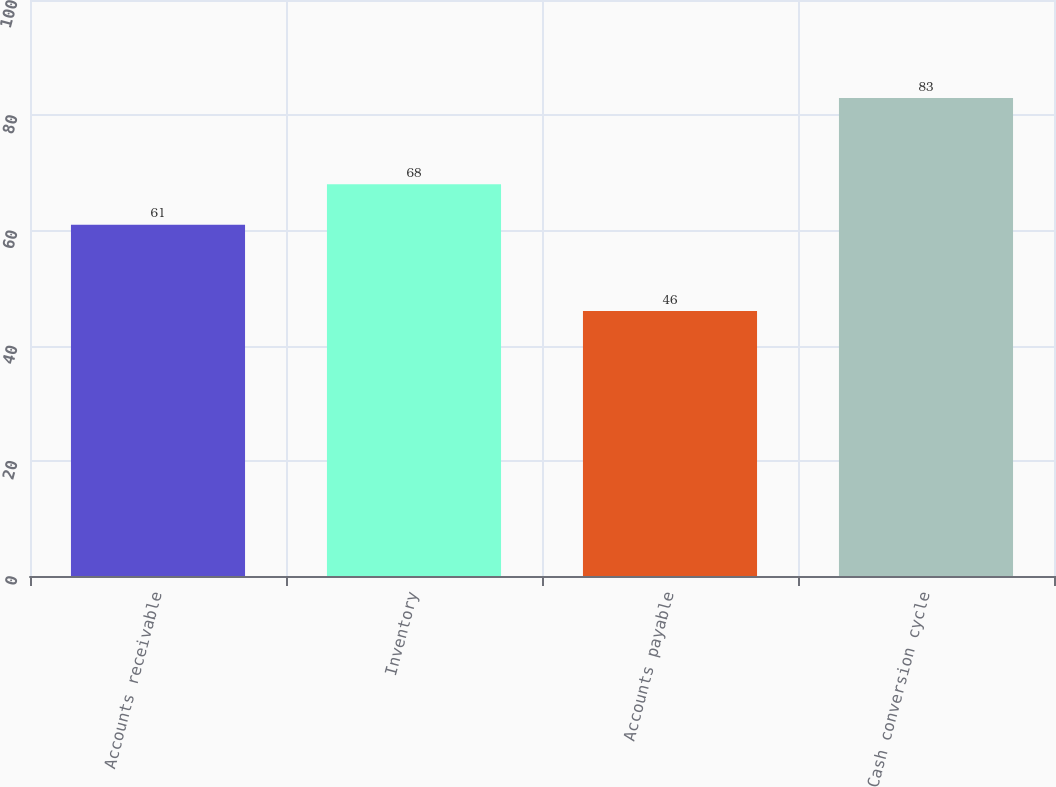Convert chart to OTSL. <chart><loc_0><loc_0><loc_500><loc_500><bar_chart><fcel>Accounts receivable<fcel>Inventory<fcel>Accounts payable<fcel>Cash conversion cycle<nl><fcel>61<fcel>68<fcel>46<fcel>83<nl></chart> 